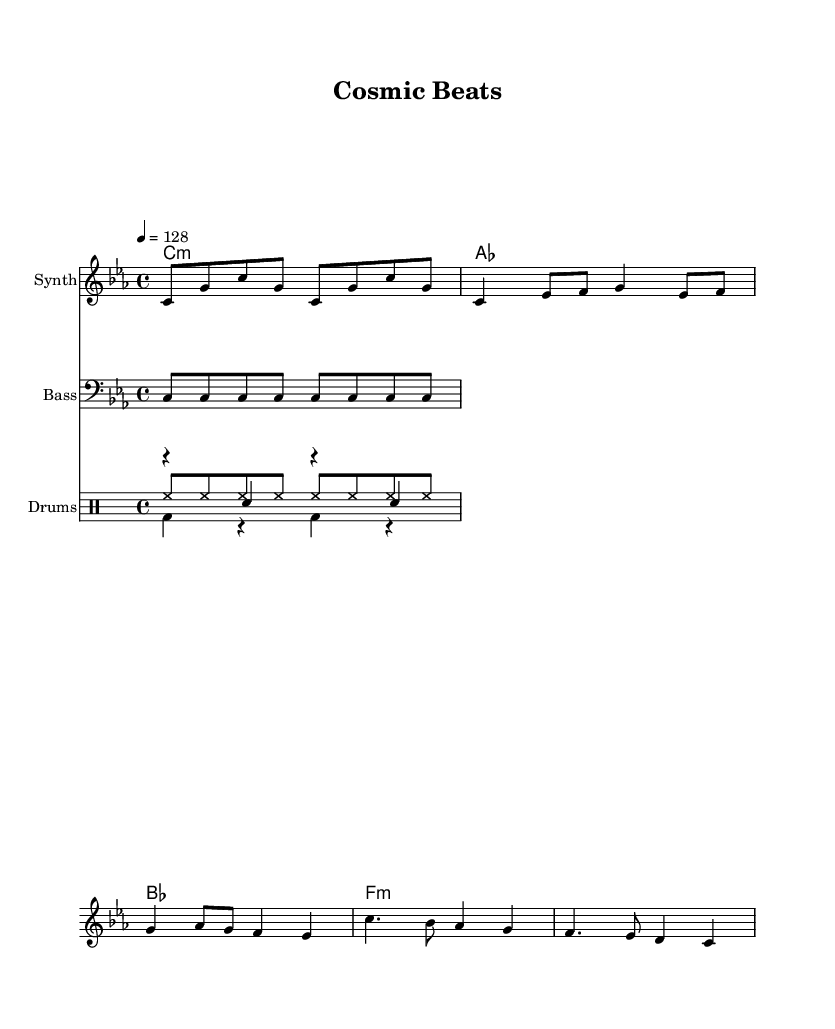What is the key signature of this music? The key signature indicates that the piece is in C minor, which has three flats (B♭, E♭, and A♭).
Answer: C minor What is the time signature of this music? The time signature is indicated as 4/4, which means there are four beats in each measure and the quarter note gets one beat.
Answer: 4/4 What is the tempo of this music? The tempo is indicated with a marking showing a quarter note gets 128 beats per minute, suggesting a fast-paced electronic dance feel.
Answer: 128 How many measures are in the given melody? By examining the melody, we can count the number of measures, which is a total of 8. Each line of the melody represents a measure in this 4/4 time signature.
Answer: 8 What instruments are represented in the score? The score includes a Synth for the melody, a Bass for the bass line, and a Drum set for the rhythm, including kick, snare, and hi-hat.
Answer: Synth, Bass, Drums What lyrical theme is presented in the text? The lyrics reference themes of space exploration, using phrases like "floating through the stars" and "exploring new horizons," which relate to astronomy and cosmic adventure.
Answer: Space exploration What type of musical genre does this piece belong to? Given the use of synthesizers, electronic elements, and dance rhythms alongside space-themed lyrics, it falls under the category of Electronic Dance Music (EDM).
Answer: Electronic Dance Music 